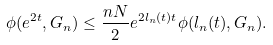Convert formula to latex. <formula><loc_0><loc_0><loc_500><loc_500>\phi ( e ^ { 2 t } , G _ { n } ) \leq \frac { n N } { 2 } e ^ { 2 l _ { n } ( t ) t } \phi ( l _ { n } ( t ) , G _ { n } ) .</formula> 